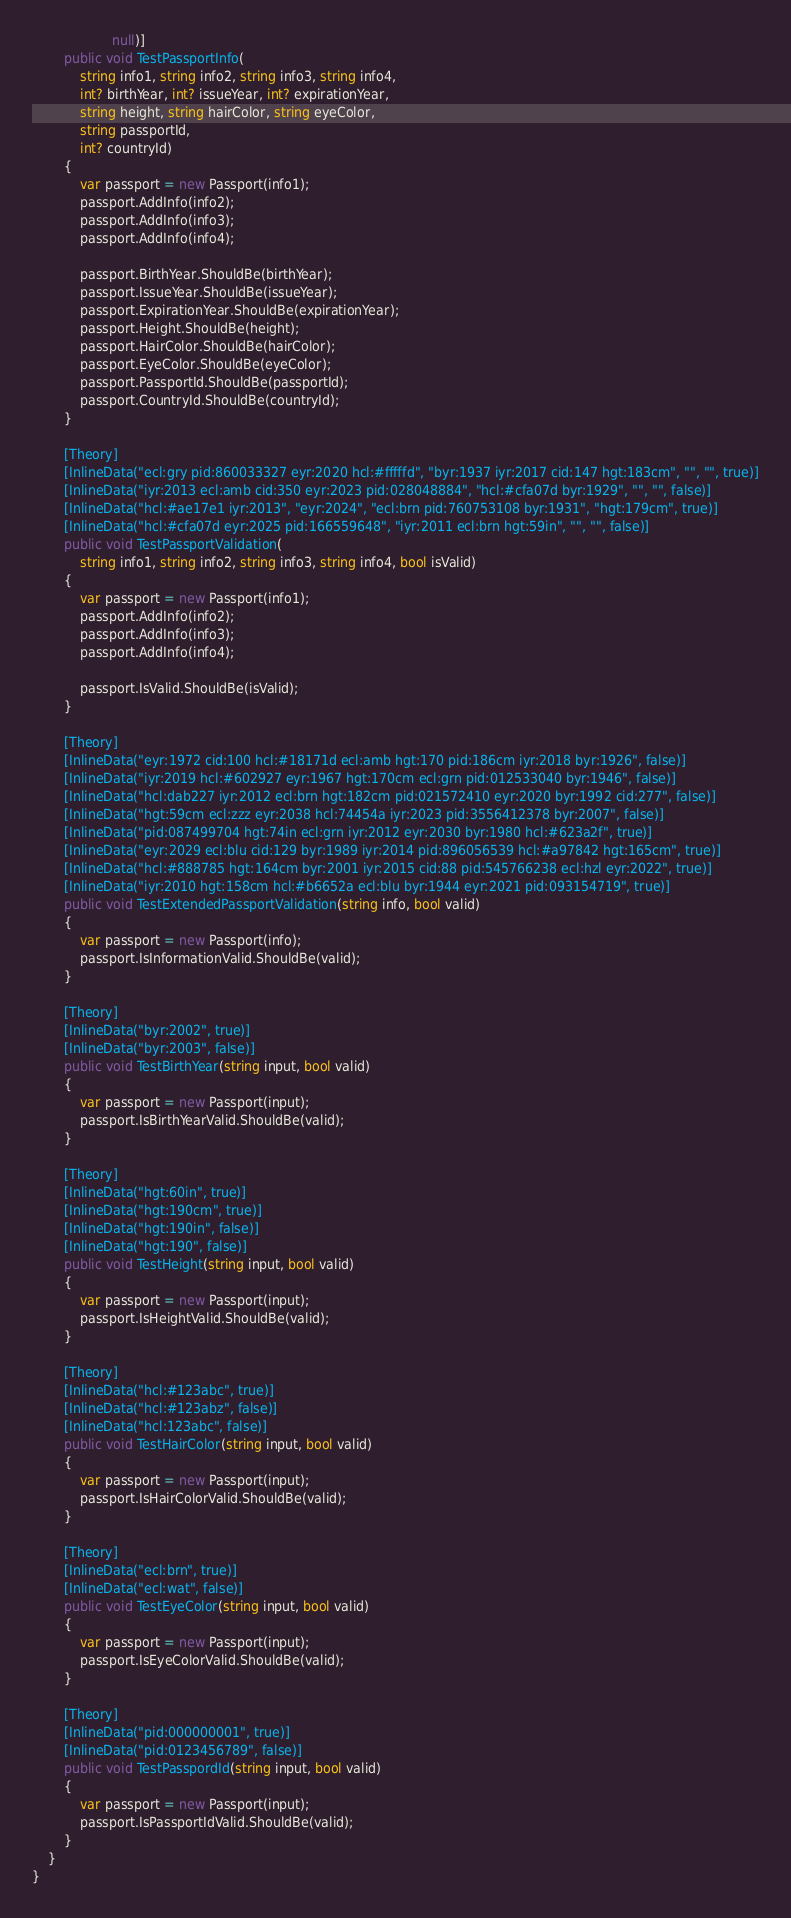<code> <loc_0><loc_0><loc_500><loc_500><_C#_>                    null)]
        public void TestPassportInfo(
            string info1, string info2, string info3, string info4,
            int? birthYear, int? issueYear, int? expirationYear,
            string height, string hairColor, string eyeColor,
            string passportId,
            int? countryId)
        {
            var passport = new Passport(info1);
            passport.AddInfo(info2);
            passport.AddInfo(info3);
            passport.AddInfo(info4);

            passport.BirthYear.ShouldBe(birthYear);
            passport.IssueYear.ShouldBe(issueYear);
            passport.ExpirationYear.ShouldBe(expirationYear);
            passport.Height.ShouldBe(height);
            passport.HairColor.ShouldBe(hairColor);
            passport.EyeColor.ShouldBe(eyeColor);
            passport.PassportId.ShouldBe(passportId);
            passport.CountryId.ShouldBe(countryId);
        }

        [Theory]
        [InlineData("ecl:gry pid:860033327 eyr:2020 hcl:#fffffd", "byr:1937 iyr:2017 cid:147 hgt:183cm", "", "", true)]
        [InlineData("iyr:2013 ecl:amb cid:350 eyr:2023 pid:028048884", "hcl:#cfa07d byr:1929", "", "", false)]
        [InlineData("hcl:#ae17e1 iyr:2013", "eyr:2024", "ecl:brn pid:760753108 byr:1931", "hgt:179cm", true)]
        [InlineData("hcl:#cfa07d eyr:2025 pid:166559648", "iyr:2011 ecl:brn hgt:59in", "", "", false)]
        public void TestPassportValidation(
            string info1, string info2, string info3, string info4, bool isValid)
        {
            var passport = new Passport(info1);
            passport.AddInfo(info2);
            passport.AddInfo(info3);
            passport.AddInfo(info4);

            passport.IsValid.ShouldBe(isValid);
        }

        [Theory]
        [InlineData("eyr:1972 cid:100 hcl:#18171d ecl:amb hgt:170 pid:186cm iyr:2018 byr:1926", false)]
        [InlineData("iyr:2019 hcl:#602927 eyr:1967 hgt:170cm ecl:grn pid:012533040 byr:1946", false)]
        [InlineData("hcl:dab227 iyr:2012 ecl:brn hgt:182cm pid:021572410 eyr:2020 byr:1992 cid:277", false)]
        [InlineData("hgt:59cm ecl:zzz eyr:2038 hcl:74454a iyr:2023 pid:3556412378 byr:2007", false)]
        [InlineData("pid:087499704 hgt:74in ecl:grn iyr:2012 eyr:2030 byr:1980 hcl:#623a2f", true)]
        [InlineData("eyr:2029 ecl:blu cid:129 byr:1989 iyr:2014 pid:896056539 hcl:#a97842 hgt:165cm", true)]
        [InlineData("hcl:#888785 hgt:164cm byr:2001 iyr:2015 cid:88 pid:545766238 ecl:hzl eyr:2022", true)]
        [InlineData("iyr:2010 hgt:158cm hcl:#b6652a ecl:blu byr:1944 eyr:2021 pid:093154719", true)]
        public void TestExtendedPassportValidation(string info, bool valid)
        {
            var passport = new Passport(info);
            passport.IsInformationValid.ShouldBe(valid);
        }

        [Theory]
        [InlineData("byr:2002", true)]
        [InlineData("byr:2003", false)]
        public void TestBirthYear(string input, bool valid)
        {
            var passport = new Passport(input);
            passport.IsBirthYearValid.ShouldBe(valid);
        }

        [Theory]
        [InlineData("hgt:60in", true)]
        [InlineData("hgt:190cm", true)]
        [InlineData("hgt:190in", false)]
        [InlineData("hgt:190", false)]
        public void TestHeight(string input, bool valid)
        {
            var passport = new Passport(input);
            passport.IsHeightValid.ShouldBe(valid);
        }

        [Theory]
        [InlineData("hcl:#123abc", true)]
        [InlineData("hcl:#123abz", false)]
        [InlineData("hcl:123abc", false)]
        public void TestHairColor(string input, bool valid)
        {
            var passport = new Passport(input);
            passport.IsHairColorValid.ShouldBe(valid);
        }

        [Theory]
        [InlineData("ecl:brn", true)]
        [InlineData("ecl:wat", false)]
        public void TestEyeColor(string input, bool valid)
        {
            var passport = new Passport(input);
            passport.IsEyeColorValid.ShouldBe(valid);
        }

        [Theory]
        [InlineData("pid:000000001", true)]
        [InlineData("pid:0123456789", false)]
        public void TestPasspordId(string input, bool valid)
        {
            var passport = new Passport(input);
            passport.IsPassportIdValid.ShouldBe(valid);
        }
    }
}
</code> 